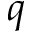Convert formula to latex. <formula><loc_0><loc_0><loc_500><loc_500>q</formula> 